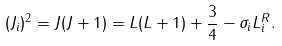Convert formula to latex. <formula><loc_0><loc_0><loc_500><loc_500>( J _ { i } ) ^ { 2 } = J ( J + 1 ) = L ( L + 1 ) + \frac { 3 } { 4 } - \sigma _ { i } L _ { i } ^ { R } .</formula> 